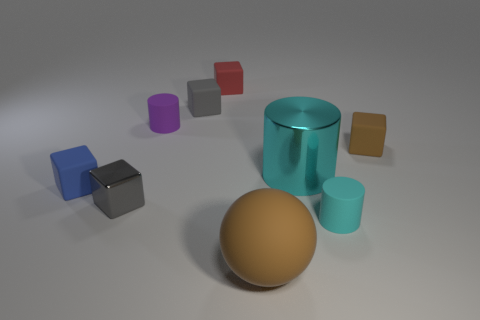What material is the small thing that is the same color as the large metal thing?
Ensure brevity in your answer.  Rubber. What is the purple object made of?
Offer a very short reply. Rubber. Is there another purple rubber object of the same shape as the tiny purple thing?
Provide a short and direct response. No. Does the shiny thing to the right of the red block have the same shape as the brown rubber object in front of the blue thing?
Provide a succinct answer. No. How many objects are either tiny red matte blocks or tiny purple matte cylinders?
Your answer should be very brief. 2. The brown thing that is the same shape as the blue thing is what size?
Your answer should be very brief. Small. Is the number of tiny matte cylinders in front of the gray metal block greater than the number of tiny yellow metallic blocks?
Provide a short and direct response. Yes. Is the small cyan cylinder made of the same material as the tiny red cube?
Provide a short and direct response. Yes. What number of objects are either small gray metal objects in front of the red cube or small rubber objects that are behind the brown block?
Provide a short and direct response. 4. There is another metal object that is the same shape as the small cyan thing; what is its color?
Ensure brevity in your answer.  Cyan. 